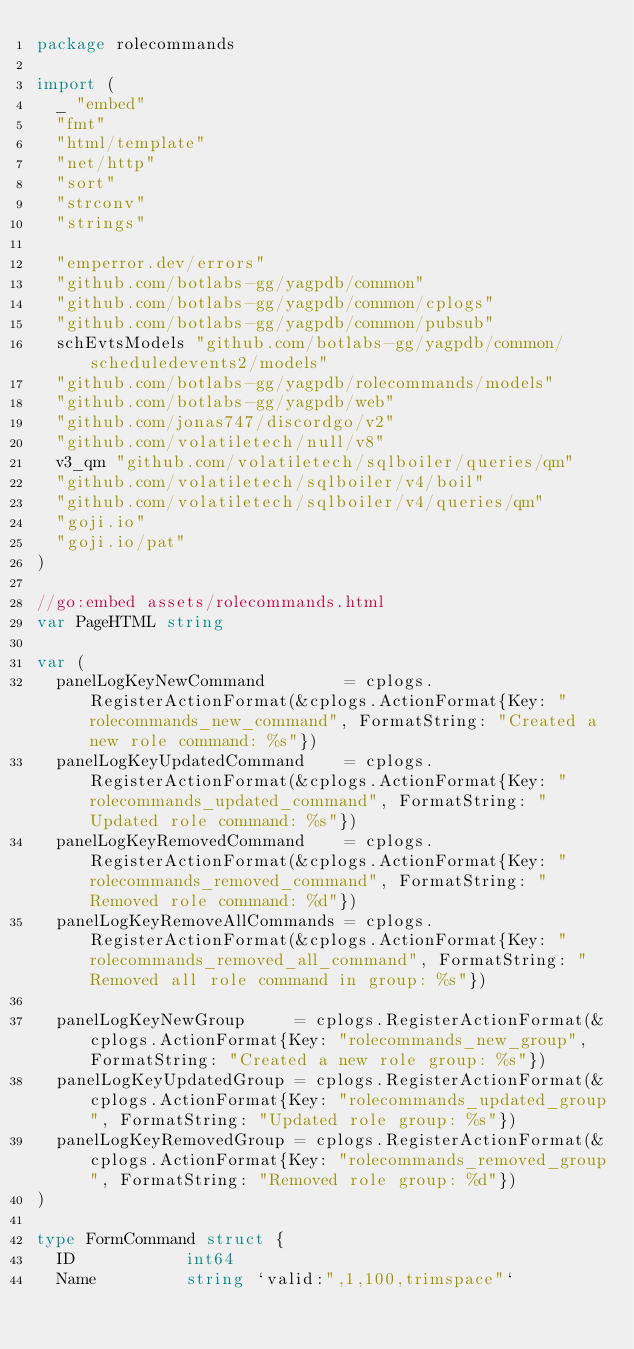<code> <loc_0><loc_0><loc_500><loc_500><_Go_>package rolecommands

import (
	_ "embed"
	"fmt"
	"html/template"
	"net/http"
	"sort"
	"strconv"
	"strings"

	"emperror.dev/errors"
	"github.com/botlabs-gg/yagpdb/common"
	"github.com/botlabs-gg/yagpdb/common/cplogs"
	"github.com/botlabs-gg/yagpdb/common/pubsub"
	schEvtsModels "github.com/botlabs-gg/yagpdb/common/scheduledevents2/models"
	"github.com/botlabs-gg/yagpdb/rolecommands/models"
	"github.com/botlabs-gg/yagpdb/web"
	"github.com/jonas747/discordgo/v2"
	"github.com/volatiletech/null/v8"
	v3_qm "github.com/volatiletech/sqlboiler/queries/qm"
	"github.com/volatiletech/sqlboiler/v4/boil"
	"github.com/volatiletech/sqlboiler/v4/queries/qm"
	"goji.io"
	"goji.io/pat"
)

//go:embed assets/rolecommands.html
var PageHTML string

var (
	panelLogKeyNewCommand        = cplogs.RegisterActionFormat(&cplogs.ActionFormat{Key: "rolecommands_new_command", FormatString: "Created a new role command: %s"})
	panelLogKeyUpdatedCommand    = cplogs.RegisterActionFormat(&cplogs.ActionFormat{Key: "rolecommands_updated_command", FormatString: "Updated role command: %s"})
	panelLogKeyRemovedCommand    = cplogs.RegisterActionFormat(&cplogs.ActionFormat{Key: "rolecommands_removed_command", FormatString: "Removed role command: %d"})
	panelLogKeyRemoveAllCommands = cplogs.RegisterActionFormat(&cplogs.ActionFormat{Key: "rolecommands_removed_all_command", FormatString: "Removed all role command in group: %s"})

	panelLogKeyNewGroup     = cplogs.RegisterActionFormat(&cplogs.ActionFormat{Key: "rolecommands_new_group", FormatString: "Created a new role group: %s"})
	panelLogKeyUpdatedGroup = cplogs.RegisterActionFormat(&cplogs.ActionFormat{Key: "rolecommands_updated_group", FormatString: "Updated role group: %s"})
	panelLogKeyRemovedGroup = cplogs.RegisterActionFormat(&cplogs.ActionFormat{Key: "rolecommands_removed_group", FormatString: "Removed role group: %d"})
)

type FormCommand struct {
	ID           int64
	Name         string `valid:",1,100,trimspace"`</code> 